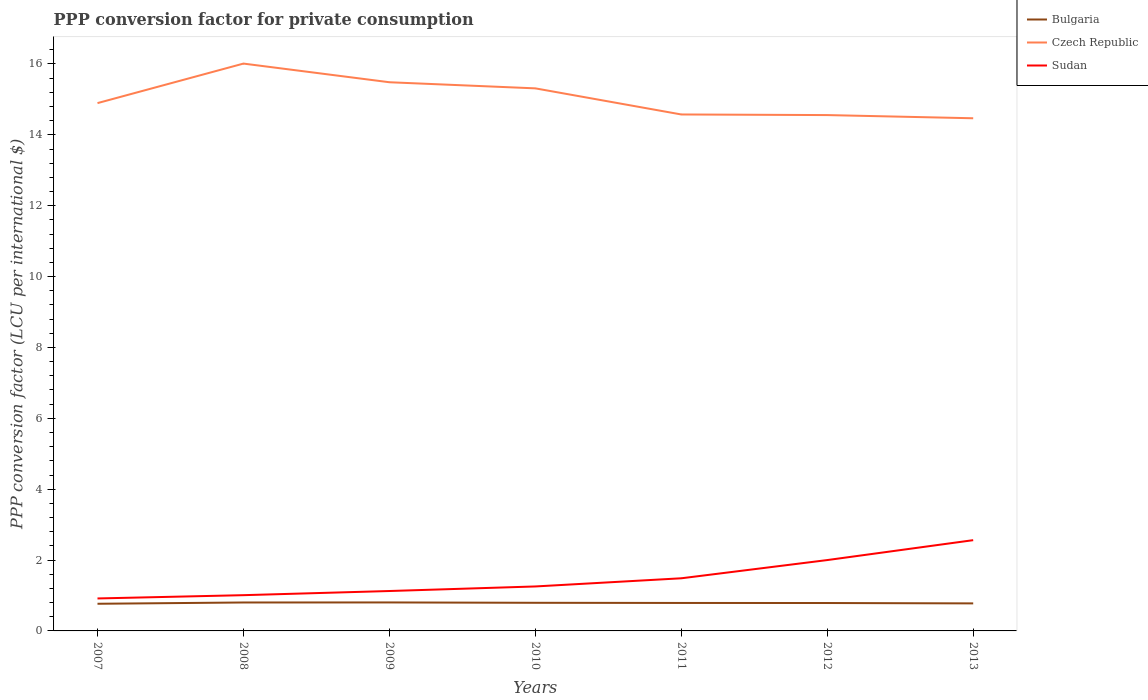Does the line corresponding to Bulgaria intersect with the line corresponding to Czech Republic?
Offer a very short reply. No. Across all years, what is the maximum PPP conversion factor for private consumption in Bulgaria?
Offer a very short reply. 0.77. In which year was the PPP conversion factor for private consumption in Czech Republic maximum?
Ensure brevity in your answer.  2013. What is the total PPP conversion factor for private consumption in Sudan in the graph?
Make the answer very short. -1.08. What is the difference between the highest and the second highest PPP conversion factor for private consumption in Czech Republic?
Offer a terse response. 1.54. What is the difference between the highest and the lowest PPP conversion factor for private consumption in Czech Republic?
Your response must be concise. 3. How many years are there in the graph?
Provide a short and direct response. 7. Are the values on the major ticks of Y-axis written in scientific E-notation?
Offer a very short reply. No. Does the graph contain grids?
Provide a short and direct response. No. Where does the legend appear in the graph?
Your answer should be compact. Top right. How are the legend labels stacked?
Provide a short and direct response. Vertical. What is the title of the graph?
Keep it short and to the point. PPP conversion factor for private consumption. Does "Brazil" appear as one of the legend labels in the graph?
Provide a succinct answer. No. What is the label or title of the X-axis?
Keep it short and to the point. Years. What is the label or title of the Y-axis?
Your answer should be compact. PPP conversion factor (LCU per international $). What is the PPP conversion factor (LCU per international $) of Bulgaria in 2007?
Keep it short and to the point. 0.77. What is the PPP conversion factor (LCU per international $) in Czech Republic in 2007?
Provide a short and direct response. 14.9. What is the PPP conversion factor (LCU per international $) in Sudan in 2007?
Provide a succinct answer. 0.92. What is the PPP conversion factor (LCU per international $) of Bulgaria in 2008?
Give a very brief answer. 0.8. What is the PPP conversion factor (LCU per international $) in Czech Republic in 2008?
Offer a very short reply. 16.01. What is the PPP conversion factor (LCU per international $) in Sudan in 2008?
Make the answer very short. 1.01. What is the PPP conversion factor (LCU per international $) in Bulgaria in 2009?
Provide a succinct answer. 0.8. What is the PPP conversion factor (LCU per international $) in Czech Republic in 2009?
Your answer should be compact. 15.48. What is the PPP conversion factor (LCU per international $) in Sudan in 2009?
Provide a succinct answer. 1.13. What is the PPP conversion factor (LCU per international $) in Bulgaria in 2010?
Give a very brief answer. 0.79. What is the PPP conversion factor (LCU per international $) in Czech Republic in 2010?
Keep it short and to the point. 15.31. What is the PPP conversion factor (LCU per international $) of Sudan in 2010?
Your answer should be compact. 1.25. What is the PPP conversion factor (LCU per international $) of Bulgaria in 2011?
Your answer should be compact. 0.79. What is the PPP conversion factor (LCU per international $) in Czech Republic in 2011?
Your answer should be compact. 14.58. What is the PPP conversion factor (LCU per international $) of Sudan in 2011?
Your response must be concise. 1.49. What is the PPP conversion factor (LCU per international $) of Bulgaria in 2012?
Make the answer very short. 0.79. What is the PPP conversion factor (LCU per international $) in Czech Republic in 2012?
Keep it short and to the point. 14.56. What is the PPP conversion factor (LCU per international $) in Sudan in 2012?
Offer a very short reply. 2. What is the PPP conversion factor (LCU per international $) of Bulgaria in 2013?
Give a very brief answer. 0.78. What is the PPP conversion factor (LCU per international $) of Czech Republic in 2013?
Your answer should be compact. 14.47. What is the PPP conversion factor (LCU per international $) in Sudan in 2013?
Keep it short and to the point. 2.56. Across all years, what is the maximum PPP conversion factor (LCU per international $) in Bulgaria?
Offer a terse response. 0.8. Across all years, what is the maximum PPP conversion factor (LCU per international $) in Czech Republic?
Keep it short and to the point. 16.01. Across all years, what is the maximum PPP conversion factor (LCU per international $) of Sudan?
Offer a terse response. 2.56. Across all years, what is the minimum PPP conversion factor (LCU per international $) of Bulgaria?
Offer a very short reply. 0.77. Across all years, what is the minimum PPP conversion factor (LCU per international $) of Czech Republic?
Your answer should be very brief. 14.47. Across all years, what is the minimum PPP conversion factor (LCU per international $) of Sudan?
Your answer should be very brief. 0.92. What is the total PPP conversion factor (LCU per international $) in Bulgaria in the graph?
Your response must be concise. 5.52. What is the total PPP conversion factor (LCU per international $) of Czech Republic in the graph?
Your answer should be very brief. 105.31. What is the total PPP conversion factor (LCU per international $) of Sudan in the graph?
Keep it short and to the point. 10.35. What is the difference between the PPP conversion factor (LCU per international $) in Bulgaria in 2007 and that in 2008?
Make the answer very short. -0.04. What is the difference between the PPP conversion factor (LCU per international $) in Czech Republic in 2007 and that in 2008?
Make the answer very short. -1.12. What is the difference between the PPP conversion factor (LCU per international $) in Sudan in 2007 and that in 2008?
Make the answer very short. -0.09. What is the difference between the PPP conversion factor (LCU per international $) in Bulgaria in 2007 and that in 2009?
Make the answer very short. -0.04. What is the difference between the PPP conversion factor (LCU per international $) in Czech Republic in 2007 and that in 2009?
Your response must be concise. -0.59. What is the difference between the PPP conversion factor (LCU per international $) of Sudan in 2007 and that in 2009?
Your answer should be compact. -0.21. What is the difference between the PPP conversion factor (LCU per international $) of Bulgaria in 2007 and that in 2010?
Keep it short and to the point. -0.03. What is the difference between the PPP conversion factor (LCU per international $) in Czech Republic in 2007 and that in 2010?
Provide a succinct answer. -0.42. What is the difference between the PPP conversion factor (LCU per international $) of Sudan in 2007 and that in 2010?
Provide a short and direct response. -0.34. What is the difference between the PPP conversion factor (LCU per international $) in Bulgaria in 2007 and that in 2011?
Provide a succinct answer. -0.02. What is the difference between the PPP conversion factor (LCU per international $) in Czech Republic in 2007 and that in 2011?
Make the answer very short. 0.32. What is the difference between the PPP conversion factor (LCU per international $) in Sudan in 2007 and that in 2011?
Your response must be concise. -0.57. What is the difference between the PPP conversion factor (LCU per international $) in Bulgaria in 2007 and that in 2012?
Provide a succinct answer. -0.02. What is the difference between the PPP conversion factor (LCU per international $) of Czech Republic in 2007 and that in 2012?
Offer a terse response. 0.34. What is the difference between the PPP conversion factor (LCU per international $) in Sudan in 2007 and that in 2012?
Give a very brief answer. -1.08. What is the difference between the PPP conversion factor (LCU per international $) of Bulgaria in 2007 and that in 2013?
Your answer should be compact. -0.01. What is the difference between the PPP conversion factor (LCU per international $) in Czech Republic in 2007 and that in 2013?
Your answer should be very brief. 0.43. What is the difference between the PPP conversion factor (LCU per international $) in Sudan in 2007 and that in 2013?
Offer a very short reply. -1.64. What is the difference between the PPP conversion factor (LCU per international $) in Bulgaria in 2008 and that in 2009?
Your answer should be compact. -0. What is the difference between the PPP conversion factor (LCU per international $) of Czech Republic in 2008 and that in 2009?
Make the answer very short. 0.53. What is the difference between the PPP conversion factor (LCU per international $) in Sudan in 2008 and that in 2009?
Your response must be concise. -0.12. What is the difference between the PPP conversion factor (LCU per international $) of Bulgaria in 2008 and that in 2010?
Offer a very short reply. 0.01. What is the difference between the PPP conversion factor (LCU per international $) in Czech Republic in 2008 and that in 2010?
Make the answer very short. 0.7. What is the difference between the PPP conversion factor (LCU per international $) in Sudan in 2008 and that in 2010?
Your answer should be compact. -0.25. What is the difference between the PPP conversion factor (LCU per international $) of Bulgaria in 2008 and that in 2011?
Your answer should be very brief. 0.01. What is the difference between the PPP conversion factor (LCU per international $) of Czech Republic in 2008 and that in 2011?
Provide a short and direct response. 1.44. What is the difference between the PPP conversion factor (LCU per international $) of Sudan in 2008 and that in 2011?
Offer a very short reply. -0.48. What is the difference between the PPP conversion factor (LCU per international $) of Bulgaria in 2008 and that in 2012?
Offer a terse response. 0.01. What is the difference between the PPP conversion factor (LCU per international $) of Czech Republic in 2008 and that in 2012?
Make the answer very short. 1.45. What is the difference between the PPP conversion factor (LCU per international $) of Sudan in 2008 and that in 2012?
Provide a succinct answer. -0.99. What is the difference between the PPP conversion factor (LCU per international $) in Bulgaria in 2008 and that in 2013?
Keep it short and to the point. 0.03. What is the difference between the PPP conversion factor (LCU per international $) of Czech Republic in 2008 and that in 2013?
Your response must be concise. 1.54. What is the difference between the PPP conversion factor (LCU per international $) of Sudan in 2008 and that in 2013?
Offer a terse response. -1.55. What is the difference between the PPP conversion factor (LCU per international $) in Bulgaria in 2009 and that in 2010?
Your answer should be compact. 0.01. What is the difference between the PPP conversion factor (LCU per international $) in Czech Republic in 2009 and that in 2010?
Offer a terse response. 0.17. What is the difference between the PPP conversion factor (LCU per international $) in Sudan in 2009 and that in 2010?
Ensure brevity in your answer.  -0.13. What is the difference between the PPP conversion factor (LCU per international $) in Bulgaria in 2009 and that in 2011?
Your response must be concise. 0.01. What is the difference between the PPP conversion factor (LCU per international $) of Czech Republic in 2009 and that in 2011?
Make the answer very short. 0.91. What is the difference between the PPP conversion factor (LCU per international $) of Sudan in 2009 and that in 2011?
Your answer should be very brief. -0.36. What is the difference between the PPP conversion factor (LCU per international $) of Bulgaria in 2009 and that in 2012?
Give a very brief answer. 0.02. What is the difference between the PPP conversion factor (LCU per international $) of Czech Republic in 2009 and that in 2012?
Your response must be concise. 0.93. What is the difference between the PPP conversion factor (LCU per international $) of Sudan in 2009 and that in 2012?
Offer a very short reply. -0.87. What is the difference between the PPP conversion factor (LCU per international $) of Bulgaria in 2009 and that in 2013?
Make the answer very short. 0.03. What is the difference between the PPP conversion factor (LCU per international $) in Czech Republic in 2009 and that in 2013?
Offer a terse response. 1.02. What is the difference between the PPP conversion factor (LCU per international $) of Sudan in 2009 and that in 2013?
Keep it short and to the point. -1.43. What is the difference between the PPP conversion factor (LCU per international $) in Bulgaria in 2010 and that in 2011?
Provide a succinct answer. 0. What is the difference between the PPP conversion factor (LCU per international $) in Czech Republic in 2010 and that in 2011?
Your answer should be compact. 0.74. What is the difference between the PPP conversion factor (LCU per international $) of Sudan in 2010 and that in 2011?
Your response must be concise. -0.23. What is the difference between the PPP conversion factor (LCU per international $) of Bulgaria in 2010 and that in 2012?
Ensure brevity in your answer.  0.01. What is the difference between the PPP conversion factor (LCU per international $) in Czech Republic in 2010 and that in 2012?
Your answer should be very brief. 0.75. What is the difference between the PPP conversion factor (LCU per international $) of Sudan in 2010 and that in 2012?
Provide a short and direct response. -0.74. What is the difference between the PPP conversion factor (LCU per international $) in Bulgaria in 2010 and that in 2013?
Make the answer very short. 0.02. What is the difference between the PPP conversion factor (LCU per international $) in Czech Republic in 2010 and that in 2013?
Provide a succinct answer. 0.84. What is the difference between the PPP conversion factor (LCU per international $) of Sudan in 2010 and that in 2013?
Make the answer very short. -1.31. What is the difference between the PPP conversion factor (LCU per international $) of Bulgaria in 2011 and that in 2012?
Offer a very short reply. 0. What is the difference between the PPP conversion factor (LCU per international $) of Czech Republic in 2011 and that in 2012?
Keep it short and to the point. 0.02. What is the difference between the PPP conversion factor (LCU per international $) of Sudan in 2011 and that in 2012?
Offer a terse response. -0.51. What is the difference between the PPP conversion factor (LCU per international $) of Bulgaria in 2011 and that in 2013?
Your answer should be very brief. 0.01. What is the difference between the PPP conversion factor (LCU per international $) in Czech Republic in 2011 and that in 2013?
Offer a very short reply. 0.11. What is the difference between the PPP conversion factor (LCU per international $) of Sudan in 2011 and that in 2013?
Offer a terse response. -1.08. What is the difference between the PPP conversion factor (LCU per international $) of Bulgaria in 2012 and that in 2013?
Provide a short and direct response. 0.01. What is the difference between the PPP conversion factor (LCU per international $) of Czech Republic in 2012 and that in 2013?
Your answer should be compact. 0.09. What is the difference between the PPP conversion factor (LCU per international $) of Sudan in 2012 and that in 2013?
Your answer should be very brief. -0.56. What is the difference between the PPP conversion factor (LCU per international $) in Bulgaria in 2007 and the PPP conversion factor (LCU per international $) in Czech Republic in 2008?
Your answer should be very brief. -15.24. What is the difference between the PPP conversion factor (LCU per international $) of Bulgaria in 2007 and the PPP conversion factor (LCU per international $) of Sudan in 2008?
Give a very brief answer. -0.24. What is the difference between the PPP conversion factor (LCU per international $) in Czech Republic in 2007 and the PPP conversion factor (LCU per international $) in Sudan in 2008?
Provide a succinct answer. 13.89. What is the difference between the PPP conversion factor (LCU per international $) in Bulgaria in 2007 and the PPP conversion factor (LCU per international $) in Czech Republic in 2009?
Offer a very short reply. -14.72. What is the difference between the PPP conversion factor (LCU per international $) in Bulgaria in 2007 and the PPP conversion factor (LCU per international $) in Sudan in 2009?
Offer a terse response. -0.36. What is the difference between the PPP conversion factor (LCU per international $) of Czech Republic in 2007 and the PPP conversion factor (LCU per international $) of Sudan in 2009?
Provide a succinct answer. 13.77. What is the difference between the PPP conversion factor (LCU per international $) of Bulgaria in 2007 and the PPP conversion factor (LCU per international $) of Czech Republic in 2010?
Your answer should be compact. -14.55. What is the difference between the PPP conversion factor (LCU per international $) in Bulgaria in 2007 and the PPP conversion factor (LCU per international $) in Sudan in 2010?
Keep it short and to the point. -0.49. What is the difference between the PPP conversion factor (LCU per international $) in Czech Republic in 2007 and the PPP conversion factor (LCU per international $) in Sudan in 2010?
Your answer should be very brief. 13.64. What is the difference between the PPP conversion factor (LCU per international $) of Bulgaria in 2007 and the PPP conversion factor (LCU per international $) of Czech Republic in 2011?
Offer a very short reply. -13.81. What is the difference between the PPP conversion factor (LCU per international $) in Bulgaria in 2007 and the PPP conversion factor (LCU per international $) in Sudan in 2011?
Provide a succinct answer. -0.72. What is the difference between the PPP conversion factor (LCU per international $) of Czech Republic in 2007 and the PPP conversion factor (LCU per international $) of Sudan in 2011?
Your answer should be compact. 13.41. What is the difference between the PPP conversion factor (LCU per international $) of Bulgaria in 2007 and the PPP conversion factor (LCU per international $) of Czech Republic in 2012?
Your answer should be very brief. -13.79. What is the difference between the PPP conversion factor (LCU per international $) in Bulgaria in 2007 and the PPP conversion factor (LCU per international $) in Sudan in 2012?
Make the answer very short. -1.23. What is the difference between the PPP conversion factor (LCU per international $) of Czech Republic in 2007 and the PPP conversion factor (LCU per international $) of Sudan in 2012?
Provide a succinct answer. 12.9. What is the difference between the PPP conversion factor (LCU per international $) of Bulgaria in 2007 and the PPP conversion factor (LCU per international $) of Czech Republic in 2013?
Ensure brevity in your answer.  -13.7. What is the difference between the PPP conversion factor (LCU per international $) in Bulgaria in 2007 and the PPP conversion factor (LCU per international $) in Sudan in 2013?
Offer a very short reply. -1.79. What is the difference between the PPP conversion factor (LCU per international $) of Czech Republic in 2007 and the PPP conversion factor (LCU per international $) of Sudan in 2013?
Your response must be concise. 12.33. What is the difference between the PPP conversion factor (LCU per international $) in Bulgaria in 2008 and the PPP conversion factor (LCU per international $) in Czech Republic in 2009?
Offer a terse response. -14.68. What is the difference between the PPP conversion factor (LCU per international $) in Bulgaria in 2008 and the PPP conversion factor (LCU per international $) in Sudan in 2009?
Offer a terse response. -0.32. What is the difference between the PPP conversion factor (LCU per international $) in Czech Republic in 2008 and the PPP conversion factor (LCU per international $) in Sudan in 2009?
Provide a succinct answer. 14.89. What is the difference between the PPP conversion factor (LCU per international $) in Bulgaria in 2008 and the PPP conversion factor (LCU per international $) in Czech Republic in 2010?
Keep it short and to the point. -14.51. What is the difference between the PPP conversion factor (LCU per international $) of Bulgaria in 2008 and the PPP conversion factor (LCU per international $) of Sudan in 2010?
Offer a very short reply. -0.45. What is the difference between the PPP conversion factor (LCU per international $) of Czech Republic in 2008 and the PPP conversion factor (LCU per international $) of Sudan in 2010?
Offer a very short reply. 14.76. What is the difference between the PPP conversion factor (LCU per international $) in Bulgaria in 2008 and the PPP conversion factor (LCU per international $) in Czech Republic in 2011?
Give a very brief answer. -13.77. What is the difference between the PPP conversion factor (LCU per international $) in Bulgaria in 2008 and the PPP conversion factor (LCU per international $) in Sudan in 2011?
Make the answer very short. -0.68. What is the difference between the PPP conversion factor (LCU per international $) in Czech Republic in 2008 and the PPP conversion factor (LCU per international $) in Sudan in 2011?
Provide a short and direct response. 14.53. What is the difference between the PPP conversion factor (LCU per international $) in Bulgaria in 2008 and the PPP conversion factor (LCU per international $) in Czech Republic in 2012?
Provide a succinct answer. -13.76. What is the difference between the PPP conversion factor (LCU per international $) of Bulgaria in 2008 and the PPP conversion factor (LCU per international $) of Sudan in 2012?
Ensure brevity in your answer.  -1.2. What is the difference between the PPP conversion factor (LCU per international $) in Czech Republic in 2008 and the PPP conversion factor (LCU per international $) in Sudan in 2012?
Your response must be concise. 14.01. What is the difference between the PPP conversion factor (LCU per international $) in Bulgaria in 2008 and the PPP conversion factor (LCU per international $) in Czech Republic in 2013?
Your answer should be very brief. -13.67. What is the difference between the PPP conversion factor (LCU per international $) in Bulgaria in 2008 and the PPP conversion factor (LCU per international $) in Sudan in 2013?
Provide a succinct answer. -1.76. What is the difference between the PPP conversion factor (LCU per international $) in Czech Republic in 2008 and the PPP conversion factor (LCU per international $) in Sudan in 2013?
Your answer should be compact. 13.45. What is the difference between the PPP conversion factor (LCU per international $) in Bulgaria in 2009 and the PPP conversion factor (LCU per international $) in Czech Republic in 2010?
Provide a short and direct response. -14.51. What is the difference between the PPP conversion factor (LCU per international $) of Bulgaria in 2009 and the PPP conversion factor (LCU per international $) of Sudan in 2010?
Ensure brevity in your answer.  -0.45. What is the difference between the PPP conversion factor (LCU per international $) of Czech Republic in 2009 and the PPP conversion factor (LCU per international $) of Sudan in 2010?
Offer a very short reply. 14.23. What is the difference between the PPP conversion factor (LCU per international $) in Bulgaria in 2009 and the PPP conversion factor (LCU per international $) in Czech Republic in 2011?
Make the answer very short. -13.77. What is the difference between the PPP conversion factor (LCU per international $) of Bulgaria in 2009 and the PPP conversion factor (LCU per international $) of Sudan in 2011?
Provide a succinct answer. -0.68. What is the difference between the PPP conversion factor (LCU per international $) in Czech Republic in 2009 and the PPP conversion factor (LCU per international $) in Sudan in 2011?
Ensure brevity in your answer.  14. What is the difference between the PPP conversion factor (LCU per international $) of Bulgaria in 2009 and the PPP conversion factor (LCU per international $) of Czech Republic in 2012?
Your response must be concise. -13.75. What is the difference between the PPP conversion factor (LCU per international $) in Bulgaria in 2009 and the PPP conversion factor (LCU per international $) in Sudan in 2012?
Provide a short and direct response. -1.2. What is the difference between the PPP conversion factor (LCU per international $) of Czech Republic in 2009 and the PPP conversion factor (LCU per international $) of Sudan in 2012?
Ensure brevity in your answer.  13.49. What is the difference between the PPP conversion factor (LCU per international $) of Bulgaria in 2009 and the PPP conversion factor (LCU per international $) of Czech Republic in 2013?
Provide a short and direct response. -13.66. What is the difference between the PPP conversion factor (LCU per international $) in Bulgaria in 2009 and the PPP conversion factor (LCU per international $) in Sudan in 2013?
Provide a short and direct response. -1.76. What is the difference between the PPP conversion factor (LCU per international $) in Czech Republic in 2009 and the PPP conversion factor (LCU per international $) in Sudan in 2013?
Provide a succinct answer. 12.92. What is the difference between the PPP conversion factor (LCU per international $) in Bulgaria in 2010 and the PPP conversion factor (LCU per international $) in Czech Republic in 2011?
Ensure brevity in your answer.  -13.78. What is the difference between the PPP conversion factor (LCU per international $) in Bulgaria in 2010 and the PPP conversion factor (LCU per international $) in Sudan in 2011?
Your answer should be very brief. -0.69. What is the difference between the PPP conversion factor (LCU per international $) in Czech Republic in 2010 and the PPP conversion factor (LCU per international $) in Sudan in 2011?
Ensure brevity in your answer.  13.83. What is the difference between the PPP conversion factor (LCU per international $) in Bulgaria in 2010 and the PPP conversion factor (LCU per international $) in Czech Republic in 2012?
Your response must be concise. -13.76. What is the difference between the PPP conversion factor (LCU per international $) in Bulgaria in 2010 and the PPP conversion factor (LCU per international $) in Sudan in 2012?
Your answer should be very brief. -1.21. What is the difference between the PPP conversion factor (LCU per international $) in Czech Republic in 2010 and the PPP conversion factor (LCU per international $) in Sudan in 2012?
Your answer should be compact. 13.31. What is the difference between the PPP conversion factor (LCU per international $) in Bulgaria in 2010 and the PPP conversion factor (LCU per international $) in Czech Republic in 2013?
Your answer should be very brief. -13.67. What is the difference between the PPP conversion factor (LCU per international $) in Bulgaria in 2010 and the PPP conversion factor (LCU per international $) in Sudan in 2013?
Give a very brief answer. -1.77. What is the difference between the PPP conversion factor (LCU per international $) in Czech Republic in 2010 and the PPP conversion factor (LCU per international $) in Sudan in 2013?
Make the answer very short. 12.75. What is the difference between the PPP conversion factor (LCU per international $) of Bulgaria in 2011 and the PPP conversion factor (LCU per international $) of Czech Republic in 2012?
Make the answer very short. -13.77. What is the difference between the PPP conversion factor (LCU per international $) of Bulgaria in 2011 and the PPP conversion factor (LCU per international $) of Sudan in 2012?
Offer a very short reply. -1.21. What is the difference between the PPP conversion factor (LCU per international $) of Czech Republic in 2011 and the PPP conversion factor (LCU per international $) of Sudan in 2012?
Offer a terse response. 12.58. What is the difference between the PPP conversion factor (LCU per international $) of Bulgaria in 2011 and the PPP conversion factor (LCU per international $) of Czech Republic in 2013?
Your answer should be compact. -13.68. What is the difference between the PPP conversion factor (LCU per international $) of Bulgaria in 2011 and the PPP conversion factor (LCU per international $) of Sudan in 2013?
Offer a very short reply. -1.77. What is the difference between the PPP conversion factor (LCU per international $) in Czech Republic in 2011 and the PPP conversion factor (LCU per international $) in Sudan in 2013?
Your answer should be very brief. 12.01. What is the difference between the PPP conversion factor (LCU per international $) of Bulgaria in 2012 and the PPP conversion factor (LCU per international $) of Czech Republic in 2013?
Your answer should be very brief. -13.68. What is the difference between the PPP conversion factor (LCU per international $) in Bulgaria in 2012 and the PPP conversion factor (LCU per international $) in Sudan in 2013?
Your answer should be very brief. -1.77. What is the difference between the PPP conversion factor (LCU per international $) of Czech Republic in 2012 and the PPP conversion factor (LCU per international $) of Sudan in 2013?
Provide a succinct answer. 12. What is the average PPP conversion factor (LCU per international $) of Bulgaria per year?
Provide a succinct answer. 0.79. What is the average PPP conversion factor (LCU per international $) in Czech Republic per year?
Your response must be concise. 15.04. What is the average PPP conversion factor (LCU per international $) of Sudan per year?
Your answer should be compact. 1.48. In the year 2007, what is the difference between the PPP conversion factor (LCU per international $) in Bulgaria and PPP conversion factor (LCU per international $) in Czech Republic?
Offer a very short reply. -14.13. In the year 2007, what is the difference between the PPP conversion factor (LCU per international $) in Bulgaria and PPP conversion factor (LCU per international $) in Sudan?
Ensure brevity in your answer.  -0.15. In the year 2007, what is the difference between the PPP conversion factor (LCU per international $) in Czech Republic and PPP conversion factor (LCU per international $) in Sudan?
Provide a succinct answer. 13.98. In the year 2008, what is the difference between the PPP conversion factor (LCU per international $) in Bulgaria and PPP conversion factor (LCU per international $) in Czech Republic?
Your answer should be very brief. -15.21. In the year 2008, what is the difference between the PPP conversion factor (LCU per international $) of Bulgaria and PPP conversion factor (LCU per international $) of Sudan?
Ensure brevity in your answer.  -0.21. In the year 2008, what is the difference between the PPP conversion factor (LCU per international $) of Czech Republic and PPP conversion factor (LCU per international $) of Sudan?
Keep it short and to the point. 15. In the year 2009, what is the difference between the PPP conversion factor (LCU per international $) in Bulgaria and PPP conversion factor (LCU per international $) in Czech Republic?
Ensure brevity in your answer.  -14.68. In the year 2009, what is the difference between the PPP conversion factor (LCU per international $) of Bulgaria and PPP conversion factor (LCU per international $) of Sudan?
Give a very brief answer. -0.32. In the year 2009, what is the difference between the PPP conversion factor (LCU per international $) of Czech Republic and PPP conversion factor (LCU per international $) of Sudan?
Your answer should be very brief. 14.36. In the year 2010, what is the difference between the PPP conversion factor (LCU per international $) of Bulgaria and PPP conversion factor (LCU per international $) of Czech Republic?
Keep it short and to the point. -14.52. In the year 2010, what is the difference between the PPP conversion factor (LCU per international $) in Bulgaria and PPP conversion factor (LCU per international $) in Sudan?
Make the answer very short. -0.46. In the year 2010, what is the difference between the PPP conversion factor (LCU per international $) of Czech Republic and PPP conversion factor (LCU per international $) of Sudan?
Give a very brief answer. 14.06. In the year 2011, what is the difference between the PPP conversion factor (LCU per international $) of Bulgaria and PPP conversion factor (LCU per international $) of Czech Republic?
Provide a short and direct response. -13.79. In the year 2011, what is the difference between the PPP conversion factor (LCU per international $) of Bulgaria and PPP conversion factor (LCU per international $) of Sudan?
Provide a succinct answer. -0.7. In the year 2011, what is the difference between the PPP conversion factor (LCU per international $) of Czech Republic and PPP conversion factor (LCU per international $) of Sudan?
Offer a very short reply. 13.09. In the year 2012, what is the difference between the PPP conversion factor (LCU per international $) of Bulgaria and PPP conversion factor (LCU per international $) of Czech Republic?
Your answer should be very brief. -13.77. In the year 2012, what is the difference between the PPP conversion factor (LCU per international $) in Bulgaria and PPP conversion factor (LCU per international $) in Sudan?
Your response must be concise. -1.21. In the year 2012, what is the difference between the PPP conversion factor (LCU per international $) of Czech Republic and PPP conversion factor (LCU per international $) of Sudan?
Give a very brief answer. 12.56. In the year 2013, what is the difference between the PPP conversion factor (LCU per international $) of Bulgaria and PPP conversion factor (LCU per international $) of Czech Republic?
Give a very brief answer. -13.69. In the year 2013, what is the difference between the PPP conversion factor (LCU per international $) in Bulgaria and PPP conversion factor (LCU per international $) in Sudan?
Your response must be concise. -1.78. In the year 2013, what is the difference between the PPP conversion factor (LCU per international $) of Czech Republic and PPP conversion factor (LCU per international $) of Sudan?
Ensure brevity in your answer.  11.91. What is the ratio of the PPP conversion factor (LCU per international $) of Bulgaria in 2007 to that in 2008?
Offer a very short reply. 0.96. What is the ratio of the PPP conversion factor (LCU per international $) in Czech Republic in 2007 to that in 2008?
Offer a very short reply. 0.93. What is the ratio of the PPP conversion factor (LCU per international $) of Sudan in 2007 to that in 2008?
Your response must be concise. 0.91. What is the ratio of the PPP conversion factor (LCU per international $) in Bulgaria in 2007 to that in 2009?
Provide a succinct answer. 0.95. What is the ratio of the PPP conversion factor (LCU per international $) in Sudan in 2007 to that in 2009?
Make the answer very short. 0.81. What is the ratio of the PPP conversion factor (LCU per international $) in Bulgaria in 2007 to that in 2010?
Give a very brief answer. 0.97. What is the ratio of the PPP conversion factor (LCU per international $) of Czech Republic in 2007 to that in 2010?
Provide a short and direct response. 0.97. What is the ratio of the PPP conversion factor (LCU per international $) of Sudan in 2007 to that in 2010?
Provide a short and direct response. 0.73. What is the ratio of the PPP conversion factor (LCU per international $) in Bulgaria in 2007 to that in 2011?
Give a very brief answer. 0.97. What is the ratio of the PPP conversion factor (LCU per international $) of Czech Republic in 2007 to that in 2011?
Provide a succinct answer. 1.02. What is the ratio of the PPP conversion factor (LCU per international $) of Sudan in 2007 to that in 2011?
Make the answer very short. 0.62. What is the ratio of the PPP conversion factor (LCU per international $) in Bulgaria in 2007 to that in 2012?
Your answer should be very brief. 0.97. What is the ratio of the PPP conversion factor (LCU per international $) of Czech Republic in 2007 to that in 2012?
Offer a terse response. 1.02. What is the ratio of the PPP conversion factor (LCU per international $) in Sudan in 2007 to that in 2012?
Provide a short and direct response. 0.46. What is the ratio of the PPP conversion factor (LCU per international $) in Bulgaria in 2007 to that in 2013?
Your answer should be very brief. 0.99. What is the ratio of the PPP conversion factor (LCU per international $) in Czech Republic in 2007 to that in 2013?
Make the answer very short. 1.03. What is the ratio of the PPP conversion factor (LCU per international $) of Sudan in 2007 to that in 2013?
Provide a succinct answer. 0.36. What is the ratio of the PPP conversion factor (LCU per international $) in Czech Republic in 2008 to that in 2009?
Provide a succinct answer. 1.03. What is the ratio of the PPP conversion factor (LCU per international $) of Sudan in 2008 to that in 2009?
Your answer should be very brief. 0.9. What is the ratio of the PPP conversion factor (LCU per international $) in Bulgaria in 2008 to that in 2010?
Offer a very short reply. 1.01. What is the ratio of the PPP conversion factor (LCU per international $) of Czech Republic in 2008 to that in 2010?
Provide a short and direct response. 1.05. What is the ratio of the PPP conversion factor (LCU per international $) of Sudan in 2008 to that in 2010?
Your response must be concise. 0.8. What is the ratio of the PPP conversion factor (LCU per international $) in Bulgaria in 2008 to that in 2011?
Your answer should be very brief. 1.02. What is the ratio of the PPP conversion factor (LCU per international $) of Czech Republic in 2008 to that in 2011?
Your response must be concise. 1.1. What is the ratio of the PPP conversion factor (LCU per international $) of Sudan in 2008 to that in 2011?
Provide a short and direct response. 0.68. What is the ratio of the PPP conversion factor (LCU per international $) of Bulgaria in 2008 to that in 2012?
Your response must be concise. 1.02. What is the ratio of the PPP conversion factor (LCU per international $) in Czech Republic in 2008 to that in 2012?
Provide a succinct answer. 1.1. What is the ratio of the PPP conversion factor (LCU per international $) of Sudan in 2008 to that in 2012?
Your response must be concise. 0.5. What is the ratio of the PPP conversion factor (LCU per international $) of Bulgaria in 2008 to that in 2013?
Keep it short and to the point. 1.03. What is the ratio of the PPP conversion factor (LCU per international $) of Czech Republic in 2008 to that in 2013?
Provide a short and direct response. 1.11. What is the ratio of the PPP conversion factor (LCU per international $) of Sudan in 2008 to that in 2013?
Make the answer very short. 0.39. What is the ratio of the PPP conversion factor (LCU per international $) of Bulgaria in 2009 to that in 2010?
Your answer should be very brief. 1.01. What is the ratio of the PPP conversion factor (LCU per international $) of Czech Republic in 2009 to that in 2010?
Make the answer very short. 1.01. What is the ratio of the PPP conversion factor (LCU per international $) in Sudan in 2009 to that in 2010?
Offer a very short reply. 0.9. What is the ratio of the PPP conversion factor (LCU per international $) in Bulgaria in 2009 to that in 2011?
Keep it short and to the point. 1.02. What is the ratio of the PPP conversion factor (LCU per international $) in Czech Republic in 2009 to that in 2011?
Provide a succinct answer. 1.06. What is the ratio of the PPP conversion factor (LCU per international $) in Sudan in 2009 to that in 2011?
Your answer should be very brief. 0.76. What is the ratio of the PPP conversion factor (LCU per international $) in Bulgaria in 2009 to that in 2012?
Provide a succinct answer. 1.02. What is the ratio of the PPP conversion factor (LCU per international $) in Czech Republic in 2009 to that in 2012?
Your answer should be very brief. 1.06. What is the ratio of the PPP conversion factor (LCU per international $) in Sudan in 2009 to that in 2012?
Make the answer very short. 0.56. What is the ratio of the PPP conversion factor (LCU per international $) in Bulgaria in 2009 to that in 2013?
Your answer should be compact. 1.03. What is the ratio of the PPP conversion factor (LCU per international $) in Czech Republic in 2009 to that in 2013?
Offer a very short reply. 1.07. What is the ratio of the PPP conversion factor (LCU per international $) of Sudan in 2009 to that in 2013?
Your response must be concise. 0.44. What is the ratio of the PPP conversion factor (LCU per international $) of Czech Republic in 2010 to that in 2011?
Your answer should be very brief. 1.05. What is the ratio of the PPP conversion factor (LCU per international $) of Sudan in 2010 to that in 2011?
Keep it short and to the point. 0.84. What is the ratio of the PPP conversion factor (LCU per international $) of Bulgaria in 2010 to that in 2012?
Make the answer very short. 1.01. What is the ratio of the PPP conversion factor (LCU per international $) in Czech Republic in 2010 to that in 2012?
Provide a short and direct response. 1.05. What is the ratio of the PPP conversion factor (LCU per international $) of Sudan in 2010 to that in 2012?
Your answer should be very brief. 0.63. What is the ratio of the PPP conversion factor (LCU per international $) of Bulgaria in 2010 to that in 2013?
Offer a terse response. 1.02. What is the ratio of the PPP conversion factor (LCU per international $) of Czech Republic in 2010 to that in 2013?
Offer a very short reply. 1.06. What is the ratio of the PPP conversion factor (LCU per international $) in Sudan in 2010 to that in 2013?
Your answer should be compact. 0.49. What is the ratio of the PPP conversion factor (LCU per international $) in Bulgaria in 2011 to that in 2012?
Keep it short and to the point. 1. What is the ratio of the PPP conversion factor (LCU per international $) of Sudan in 2011 to that in 2012?
Give a very brief answer. 0.74. What is the ratio of the PPP conversion factor (LCU per international $) in Bulgaria in 2011 to that in 2013?
Give a very brief answer. 1.02. What is the ratio of the PPP conversion factor (LCU per international $) of Czech Republic in 2011 to that in 2013?
Give a very brief answer. 1.01. What is the ratio of the PPP conversion factor (LCU per international $) of Sudan in 2011 to that in 2013?
Ensure brevity in your answer.  0.58. What is the ratio of the PPP conversion factor (LCU per international $) of Bulgaria in 2012 to that in 2013?
Ensure brevity in your answer.  1.01. What is the ratio of the PPP conversion factor (LCU per international $) of Sudan in 2012 to that in 2013?
Make the answer very short. 0.78. What is the difference between the highest and the second highest PPP conversion factor (LCU per international $) of Bulgaria?
Provide a succinct answer. 0. What is the difference between the highest and the second highest PPP conversion factor (LCU per international $) in Czech Republic?
Keep it short and to the point. 0.53. What is the difference between the highest and the second highest PPP conversion factor (LCU per international $) in Sudan?
Keep it short and to the point. 0.56. What is the difference between the highest and the lowest PPP conversion factor (LCU per international $) in Bulgaria?
Offer a very short reply. 0.04. What is the difference between the highest and the lowest PPP conversion factor (LCU per international $) of Czech Republic?
Provide a short and direct response. 1.54. What is the difference between the highest and the lowest PPP conversion factor (LCU per international $) of Sudan?
Give a very brief answer. 1.64. 